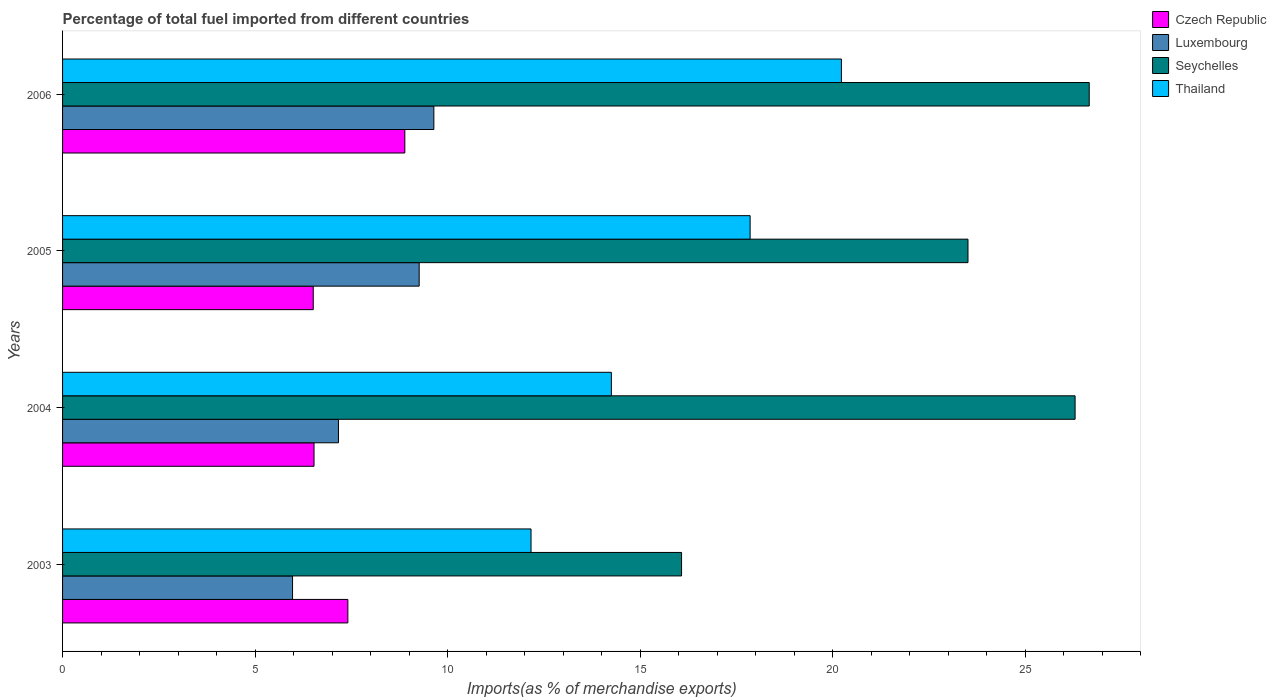How many different coloured bars are there?
Provide a short and direct response. 4. How many groups of bars are there?
Offer a very short reply. 4. How many bars are there on the 2nd tick from the bottom?
Provide a succinct answer. 4. What is the label of the 3rd group of bars from the top?
Keep it short and to the point. 2004. In how many cases, is the number of bars for a given year not equal to the number of legend labels?
Provide a succinct answer. 0. What is the percentage of imports to different countries in Czech Republic in 2006?
Give a very brief answer. 8.89. Across all years, what is the maximum percentage of imports to different countries in Luxembourg?
Give a very brief answer. 9.64. Across all years, what is the minimum percentage of imports to different countries in Seychelles?
Your response must be concise. 16.08. In which year was the percentage of imports to different countries in Seychelles minimum?
Make the answer very short. 2003. What is the total percentage of imports to different countries in Czech Republic in the graph?
Ensure brevity in your answer.  29.34. What is the difference between the percentage of imports to different countries in Czech Republic in 2005 and that in 2006?
Your answer should be compact. -2.38. What is the difference between the percentage of imports to different countries in Czech Republic in 2006 and the percentage of imports to different countries in Seychelles in 2003?
Keep it short and to the point. -7.19. What is the average percentage of imports to different countries in Seychelles per year?
Your answer should be very brief. 23.14. In the year 2006, what is the difference between the percentage of imports to different countries in Seychelles and percentage of imports to different countries in Czech Republic?
Ensure brevity in your answer.  17.78. What is the ratio of the percentage of imports to different countries in Czech Republic in 2005 to that in 2006?
Make the answer very short. 0.73. Is the difference between the percentage of imports to different countries in Seychelles in 2003 and 2004 greater than the difference between the percentage of imports to different countries in Czech Republic in 2003 and 2004?
Give a very brief answer. No. What is the difference between the highest and the second highest percentage of imports to different countries in Seychelles?
Ensure brevity in your answer.  0.37. What is the difference between the highest and the lowest percentage of imports to different countries in Thailand?
Your answer should be very brief. 8.06. In how many years, is the percentage of imports to different countries in Thailand greater than the average percentage of imports to different countries in Thailand taken over all years?
Your answer should be compact. 2. Is the sum of the percentage of imports to different countries in Seychelles in 2004 and 2005 greater than the maximum percentage of imports to different countries in Luxembourg across all years?
Ensure brevity in your answer.  Yes. What does the 3rd bar from the top in 2003 represents?
Provide a short and direct response. Luxembourg. What does the 1st bar from the bottom in 2006 represents?
Offer a very short reply. Czech Republic. Is it the case that in every year, the sum of the percentage of imports to different countries in Seychelles and percentage of imports to different countries in Czech Republic is greater than the percentage of imports to different countries in Luxembourg?
Make the answer very short. Yes. How many bars are there?
Offer a very short reply. 16. Are all the bars in the graph horizontal?
Your response must be concise. Yes. How many years are there in the graph?
Provide a short and direct response. 4. What is the difference between two consecutive major ticks on the X-axis?
Ensure brevity in your answer.  5. Does the graph contain any zero values?
Your answer should be compact. No. Does the graph contain grids?
Your answer should be compact. No. How many legend labels are there?
Make the answer very short. 4. What is the title of the graph?
Provide a succinct answer. Percentage of total fuel imported from different countries. What is the label or title of the X-axis?
Keep it short and to the point. Imports(as % of merchandise exports). What is the Imports(as % of merchandise exports) of Czech Republic in 2003?
Offer a terse response. 7.41. What is the Imports(as % of merchandise exports) of Luxembourg in 2003?
Keep it short and to the point. 5.97. What is the Imports(as % of merchandise exports) in Seychelles in 2003?
Provide a succinct answer. 16.08. What is the Imports(as % of merchandise exports) of Thailand in 2003?
Offer a very short reply. 12.17. What is the Imports(as % of merchandise exports) of Czech Republic in 2004?
Provide a short and direct response. 6.53. What is the Imports(as % of merchandise exports) of Luxembourg in 2004?
Make the answer very short. 7.17. What is the Imports(as % of merchandise exports) in Seychelles in 2004?
Keep it short and to the point. 26.3. What is the Imports(as % of merchandise exports) in Thailand in 2004?
Your answer should be very brief. 14.26. What is the Imports(as % of merchandise exports) of Czech Republic in 2005?
Give a very brief answer. 6.51. What is the Imports(as % of merchandise exports) in Luxembourg in 2005?
Your answer should be very brief. 9.26. What is the Imports(as % of merchandise exports) of Seychelles in 2005?
Offer a terse response. 23.52. What is the Imports(as % of merchandise exports) in Thailand in 2005?
Your answer should be very brief. 17.86. What is the Imports(as % of merchandise exports) of Czech Republic in 2006?
Keep it short and to the point. 8.89. What is the Imports(as % of merchandise exports) in Luxembourg in 2006?
Provide a succinct answer. 9.64. What is the Imports(as % of merchandise exports) in Seychelles in 2006?
Your response must be concise. 26.67. What is the Imports(as % of merchandise exports) of Thailand in 2006?
Ensure brevity in your answer.  20.23. Across all years, what is the maximum Imports(as % of merchandise exports) in Czech Republic?
Give a very brief answer. 8.89. Across all years, what is the maximum Imports(as % of merchandise exports) of Luxembourg?
Offer a terse response. 9.64. Across all years, what is the maximum Imports(as % of merchandise exports) in Seychelles?
Offer a terse response. 26.67. Across all years, what is the maximum Imports(as % of merchandise exports) in Thailand?
Give a very brief answer. 20.23. Across all years, what is the minimum Imports(as % of merchandise exports) of Czech Republic?
Make the answer very short. 6.51. Across all years, what is the minimum Imports(as % of merchandise exports) of Luxembourg?
Your answer should be very brief. 5.97. Across all years, what is the minimum Imports(as % of merchandise exports) of Seychelles?
Your response must be concise. 16.08. Across all years, what is the minimum Imports(as % of merchandise exports) in Thailand?
Your answer should be compact. 12.17. What is the total Imports(as % of merchandise exports) of Czech Republic in the graph?
Offer a very short reply. 29.34. What is the total Imports(as % of merchandise exports) in Luxembourg in the graph?
Ensure brevity in your answer.  32.05. What is the total Imports(as % of merchandise exports) of Seychelles in the graph?
Make the answer very short. 92.56. What is the total Imports(as % of merchandise exports) in Thailand in the graph?
Give a very brief answer. 64.51. What is the difference between the Imports(as % of merchandise exports) of Czech Republic in 2003 and that in 2004?
Offer a very short reply. 0.88. What is the difference between the Imports(as % of merchandise exports) of Luxembourg in 2003 and that in 2004?
Provide a succinct answer. -1.19. What is the difference between the Imports(as % of merchandise exports) in Seychelles in 2003 and that in 2004?
Your response must be concise. -10.22. What is the difference between the Imports(as % of merchandise exports) in Thailand in 2003 and that in 2004?
Ensure brevity in your answer.  -2.09. What is the difference between the Imports(as % of merchandise exports) of Czech Republic in 2003 and that in 2005?
Offer a very short reply. 0.9. What is the difference between the Imports(as % of merchandise exports) in Luxembourg in 2003 and that in 2005?
Offer a terse response. -3.29. What is the difference between the Imports(as % of merchandise exports) of Seychelles in 2003 and that in 2005?
Make the answer very short. -7.44. What is the difference between the Imports(as % of merchandise exports) of Thailand in 2003 and that in 2005?
Offer a very short reply. -5.69. What is the difference between the Imports(as % of merchandise exports) in Czech Republic in 2003 and that in 2006?
Ensure brevity in your answer.  -1.48. What is the difference between the Imports(as % of merchandise exports) in Luxembourg in 2003 and that in 2006?
Ensure brevity in your answer.  -3.67. What is the difference between the Imports(as % of merchandise exports) in Seychelles in 2003 and that in 2006?
Your answer should be very brief. -10.59. What is the difference between the Imports(as % of merchandise exports) of Thailand in 2003 and that in 2006?
Give a very brief answer. -8.06. What is the difference between the Imports(as % of merchandise exports) of Czech Republic in 2004 and that in 2005?
Make the answer very short. 0.02. What is the difference between the Imports(as % of merchandise exports) of Luxembourg in 2004 and that in 2005?
Offer a terse response. -2.1. What is the difference between the Imports(as % of merchandise exports) of Seychelles in 2004 and that in 2005?
Offer a very short reply. 2.78. What is the difference between the Imports(as % of merchandise exports) in Thailand in 2004 and that in 2005?
Ensure brevity in your answer.  -3.6. What is the difference between the Imports(as % of merchandise exports) of Czech Republic in 2004 and that in 2006?
Your answer should be compact. -2.36. What is the difference between the Imports(as % of merchandise exports) of Luxembourg in 2004 and that in 2006?
Offer a terse response. -2.48. What is the difference between the Imports(as % of merchandise exports) in Seychelles in 2004 and that in 2006?
Offer a terse response. -0.37. What is the difference between the Imports(as % of merchandise exports) in Thailand in 2004 and that in 2006?
Offer a terse response. -5.97. What is the difference between the Imports(as % of merchandise exports) of Czech Republic in 2005 and that in 2006?
Provide a short and direct response. -2.38. What is the difference between the Imports(as % of merchandise exports) in Luxembourg in 2005 and that in 2006?
Make the answer very short. -0.38. What is the difference between the Imports(as % of merchandise exports) of Seychelles in 2005 and that in 2006?
Give a very brief answer. -3.15. What is the difference between the Imports(as % of merchandise exports) of Thailand in 2005 and that in 2006?
Provide a succinct answer. -2.37. What is the difference between the Imports(as % of merchandise exports) in Czech Republic in 2003 and the Imports(as % of merchandise exports) in Luxembourg in 2004?
Make the answer very short. 0.24. What is the difference between the Imports(as % of merchandise exports) of Czech Republic in 2003 and the Imports(as % of merchandise exports) of Seychelles in 2004?
Your answer should be very brief. -18.89. What is the difference between the Imports(as % of merchandise exports) of Czech Republic in 2003 and the Imports(as % of merchandise exports) of Thailand in 2004?
Keep it short and to the point. -6.84. What is the difference between the Imports(as % of merchandise exports) in Luxembourg in 2003 and the Imports(as % of merchandise exports) in Seychelles in 2004?
Provide a short and direct response. -20.33. What is the difference between the Imports(as % of merchandise exports) of Luxembourg in 2003 and the Imports(as % of merchandise exports) of Thailand in 2004?
Ensure brevity in your answer.  -8.28. What is the difference between the Imports(as % of merchandise exports) of Seychelles in 2003 and the Imports(as % of merchandise exports) of Thailand in 2004?
Keep it short and to the point. 1.82. What is the difference between the Imports(as % of merchandise exports) of Czech Republic in 2003 and the Imports(as % of merchandise exports) of Luxembourg in 2005?
Provide a short and direct response. -1.85. What is the difference between the Imports(as % of merchandise exports) of Czech Republic in 2003 and the Imports(as % of merchandise exports) of Seychelles in 2005?
Your answer should be very brief. -16.11. What is the difference between the Imports(as % of merchandise exports) in Czech Republic in 2003 and the Imports(as % of merchandise exports) in Thailand in 2005?
Your response must be concise. -10.45. What is the difference between the Imports(as % of merchandise exports) in Luxembourg in 2003 and the Imports(as % of merchandise exports) in Seychelles in 2005?
Make the answer very short. -17.54. What is the difference between the Imports(as % of merchandise exports) in Luxembourg in 2003 and the Imports(as % of merchandise exports) in Thailand in 2005?
Ensure brevity in your answer.  -11.89. What is the difference between the Imports(as % of merchandise exports) in Seychelles in 2003 and the Imports(as % of merchandise exports) in Thailand in 2005?
Make the answer very short. -1.78. What is the difference between the Imports(as % of merchandise exports) of Czech Republic in 2003 and the Imports(as % of merchandise exports) of Luxembourg in 2006?
Provide a succinct answer. -2.23. What is the difference between the Imports(as % of merchandise exports) in Czech Republic in 2003 and the Imports(as % of merchandise exports) in Seychelles in 2006?
Provide a succinct answer. -19.26. What is the difference between the Imports(as % of merchandise exports) of Czech Republic in 2003 and the Imports(as % of merchandise exports) of Thailand in 2006?
Provide a succinct answer. -12.82. What is the difference between the Imports(as % of merchandise exports) in Luxembourg in 2003 and the Imports(as % of merchandise exports) in Seychelles in 2006?
Keep it short and to the point. -20.69. What is the difference between the Imports(as % of merchandise exports) of Luxembourg in 2003 and the Imports(as % of merchandise exports) of Thailand in 2006?
Make the answer very short. -14.26. What is the difference between the Imports(as % of merchandise exports) in Seychelles in 2003 and the Imports(as % of merchandise exports) in Thailand in 2006?
Provide a short and direct response. -4.15. What is the difference between the Imports(as % of merchandise exports) of Czech Republic in 2004 and the Imports(as % of merchandise exports) of Luxembourg in 2005?
Your answer should be compact. -2.73. What is the difference between the Imports(as % of merchandise exports) of Czech Republic in 2004 and the Imports(as % of merchandise exports) of Seychelles in 2005?
Offer a terse response. -16.99. What is the difference between the Imports(as % of merchandise exports) in Czech Republic in 2004 and the Imports(as % of merchandise exports) in Thailand in 2005?
Give a very brief answer. -11.33. What is the difference between the Imports(as % of merchandise exports) in Luxembourg in 2004 and the Imports(as % of merchandise exports) in Seychelles in 2005?
Provide a succinct answer. -16.35. What is the difference between the Imports(as % of merchandise exports) of Luxembourg in 2004 and the Imports(as % of merchandise exports) of Thailand in 2005?
Keep it short and to the point. -10.69. What is the difference between the Imports(as % of merchandise exports) in Seychelles in 2004 and the Imports(as % of merchandise exports) in Thailand in 2005?
Your answer should be compact. 8.44. What is the difference between the Imports(as % of merchandise exports) of Czech Republic in 2004 and the Imports(as % of merchandise exports) of Luxembourg in 2006?
Ensure brevity in your answer.  -3.11. What is the difference between the Imports(as % of merchandise exports) in Czech Republic in 2004 and the Imports(as % of merchandise exports) in Seychelles in 2006?
Keep it short and to the point. -20.14. What is the difference between the Imports(as % of merchandise exports) of Czech Republic in 2004 and the Imports(as % of merchandise exports) of Thailand in 2006?
Ensure brevity in your answer.  -13.7. What is the difference between the Imports(as % of merchandise exports) of Luxembourg in 2004 and the Imports(as % of merchandise exports) of Seychelles in 2006?
Keep it short and to the point. -19.5. What is the difference between the Imports(as % of merchandise exports) in Luxembourg in 2004 and the Imports(as % of merchandise exports) in Thailand in 2006?
Your answer should be very brief. -13.06. What is the difference between the Imports(as % of merchandise exports) in Seychelles in 2004 and the Imports(as % of merchandise exports) in Thailand in 2006?
Your answer should be very brief. 6.07. What is the difference between the Imports(as % of merchandise exports) in Czech Republic in 2005 and the Imports(as % of merchandise exports) in Luxembourg in 2006?
Keep it short and to the point. -3.13. What is the difference between the Imports(as % of merchandise exports) in Czech Republic in 2005 and the Imports(as % of merchandise exports) in Seychelles in 2006?
Provide a succinct answer. -20.16. What is the difference between the Imports(as % of merchandise exports) of Czech Republic in 2005 and the Imports(as % of merchandise exports) of Thailand in 2006?
Make the answer very short. -13.72. What is the difference between the Imports(as % of merchandise exports) of Luxembourg in 2005 and the Imports(as % of merchandise exports) of Seychelles in 2006?
Offer a terse response. -17.4. What is the difference between the Imports(as % of merchandise exports) of Luxembourg in 2005 and the Imports(as % of merchandise exports) of Thailand in 2006?
Keep it short and to the point. -10.97. What is the difference between the Imports(as % of merchandise exports) of Seychelles in 2005 and the Imports(as % of merchandise exports) of Thailand in 2006?
Your answer should be very brief. 3.29. What is the average Imports(as % of merchandise exports) of Czech Republic per year?
Provide a short and direct response. 7.34. What is the average Imports(as % of merchandise exports) of Luxembourg per year?
Your response must be concise. 8.01. What is the average Imports(as % of merchandise exports) of Seychelles per year?
Your response must be concise. 23.14. What is the average Imports(as % of merchandise exports) in Thailand per year?
Keep it short and to the point. 16.13. In the year 2003, what is the difference between the Imports(as % of merchandise exports) of Czech Republic and Imports(as % of merchandise exports) of Luxembourg?
Keep it short and to the point. 1.44. In the year 2003, what is the difference between the Imports(as % of merchandise exports) in Czech Republic and Imports(as % of merchandise exports) in Seychelles?
Provide a succinct answer. -8.67. In the year 2003, what is the difference between the Imports(as % of merchandise exports) in Czech Republic and Imports(as % of merchandise exports) in Thailand?
Your response must be concise. -4.76. In the year 2003, what is the difference between the Imports(as % of merchandise exports) of Luxembourg and Imports(as % of merchandise exports) of Seychelles?
Your response must be concise. -10.1. In the year 2003, what is the difference between the Imports(as % of merchandise exports) of Luxembourg and Imports(as % of merchandise exports) of Thailand?
Your response must be concise. -6.19. In the year 2003, what is the difference between the Imports(as % of merchandise exports) of Seychelles and Imports(as % of merchandise exports) of Thailand?
Make the answer very short. 3.91. In the year 2004, what is the difference between the Imports(as % of merchandise exports) in Czech Republic and Imports(as % of merchandise exports) in Luxembourg?
Provide a succinct answer. -0.63. In the year 2004, what is the difference between the Imports(as % of merchandise exports) in Czech Republic and Imports(as % of merchandise exports) in Seychelles?
Ensure brevity in your answer.  -19.77. In the year 2004, what is the difference between the Imports(as % of merchandise exports) of Czech Republic and Imports(as % of merchandise exports) of Thailand?
Your answer should be compact. -7.72. In the year 2004, what is the difference between the Imports(as % of merchandise exports) in Luxembourg and Imports(as % of merchandise exports) in Seychelles?
Your response must be concise. -19.13. In the year 2004, what is the difference between the Imports(as % of merchandise exports) in Luxembourg and Imports(as % of merchandise exports) in Thailand?
Your response must be concise. -7.09. In the year 2004, what is the difference between the Imports(as % of merchandise exports) in Seychelles and Imports(as % of merchandise exports) in Thailand?
Provide a succinct answer. 12.04. In the year 2005, what is the difference between the Imports(as % of merchandise exports) of Czech Republic and Imports(as % of merchandise exports) of Luxembourg?
Your response must be concise. -2.75. In the year 2005, what is the difference between the Imports(as % of merchandise exports) of Czech Republic and Imports(as % of merchandise exports) of Seychelles?
Your response must be concise. -17.01. In the year 2005, what is the difference between the Imports(as % of merchandise exports) of Czech Republic and Imports(as % of merchandise exports) of Thailand?
Make the answer very short. -11.35. In the year 2005, what is the difference between the Imports(as % of merchandise exports) of Luxembourg and Imports(as % of merchandise exports) of Seychelles?
Provide a succinct answer. -14.25. In the year 2005, what is the difference between the Imports(as % of merchandise exports) in Luxembourg and Imports(as % of merchandise exports) in Thailand?
Provide a short and direct response. -8.6. In the year 2005, what is the difference between the Imports(as % of merchandise exports) of Seychelles and Imports(as % of merchandise exports) of Thailand?
Give a very brief answer. 5.66. In the year 2006, what is the difference between the Imports(as % of merchandise exports) in Czech Republic and Imports(as % of merchandise exports) in Luxembourg?
Provide a succinct answer. -0.75. In the year 2006, what is the difference between the Imports(as % of merchandise exports) in Czech Republic and Imports(as % of merchandise exports) in Seychelles?
Provide a succinct answer. -17.78. In the year 2006, what is the difference between the Imports(as % of merchandise exports) in Czech Republic and Imports(as % of merchandise exports) in Thailand?
Offer a terse response. -11.34. In the year 2006, what is the difference between the Imports(as % of merchandise exports) in Luxembourg and Imports(as % of merchandise exports) in Seychelles?
Your response must be concise. -17.02. In the year 2006, what is the difference between the Imports(as % of merchandise exports) in Luxembourg and Imports(as % of merchandise exports) in Thailand?
Ensure brevity in your answer.  -10.59. In the year 2006, what is the difference between the Imports(as % of merchandise exports) in Seychelles and Imports(as % of merchandise exports) in Thailand?
Offer a terse response. 6.44. What is the ratio of the Imports(as % of merchandise exports) in Czech Republic in 2003 to that in 2004?
Provide a short and direct response. 1.13. What is the ratio of the Imports(as % of merchandise exports) in Luxembourg in 2003 to that in 2004?
Offer a very short reply. 0.83. What is the ratio of the Imports(as % of merchandise exports) of Seychelles in 2003 to that in 2004?
Provide a short and direct response. 0.61. What is the ratio of the Imports(as % of merchandise exports) in Thailand in 2003 to that in 2004?
Offer a very short reply. 0.85. What is the ratio of the Imports(as % of merchandise exports) of Czech Republic in 2003 to that in 2005?
Give a very brief answer. 1.14. What is the ratio of the Imports(as % of merchandise exports) in Luxembourg in 2003 to that in 2005?
Offer a terse response. 0.64. What is the ratio of the Imports(as % of merchandise exports) in Seychelles in 2003 to that in 2005?
Keep it short and to the point. 0.68. What is the ratio of the Imports(as % of merchandise exports) in Thailand in 2003 to that in 2005?
Make the answer very short. 0.68. What is the ratio of the Imports(as % of merchandise exports) of Czech Republic in 2003 to that in 2006?
Offer a terse response. 0.83. What is the ratio of the Imports(as % of merchandise exports) in Luxembourg in 2003 to that in 2006?
Make the answer very short. 0.62. What is the ratio of the Imports(as % of merchandise exports) of Seychelles in 2003 to that in 2006?
Keep it short and to the point. 0.6. What is the ratio of the Imports(as % of merchandise exports) of Thailand in 2003 to that in 2006?
Offer a terse response. 0.6. What is the ratio of the Imports(as % of merchandise exports) in Czech Republic in 2004 to that in 2005?
Give a very brief answer. 1. What is the ratio of the Imports(as % of merchandise exports) in Luxembourg in 2004 to that in 2005?
Give a very brief answer. 0.77. What is the ratio of the Imports(as % of merchandise exports) of Seychelles in 2004 to that in 2005?
Make the answer very short. 1.12. What is the ratio of the Imports(as % of merchandise exports) of Thailand in 2004 to that in 2005?
Your answer should be compact. 0.8. What is the ratio of the Imports(as % of merchandise exports) of Czech Republic in 2004 to that in 2006?
Your response must be concise. 0.73. What is the ratio of the Imports(as % of merchandise exports) in Luxembourg in 2004 to that in 2006?
Offer a terse response. 0.74. What is the ratio of the Imports(as % of merchandise exports) in Seychelles in 2004 to that in 2006?
Offer a very short reply. 0.99. What is the ratio of the Imports(as % of merchandise exports) in Thailand in 2004 to that in 2006?
Your response must be concise. 0.7. What is the ratio of the Imports(as % of merchandise exports) in Czech Republic in 2005 to that in 2006?
Keep it short and to the point. 0.73. What is the ratio of the Imports(as % of merchandise exports) in Luxembourg in 2005 to that in 2006?
Ensure brevity in your answer.  0.96. What is the ratio of the Imports(as % of merchandise exports) of Seychelles in 2005 to that in 2006?
Your answer should be compact. 0.88. What is the ratio of the Imports(as % of merchandise exports) in Thailand in 2005 to that in 2006?
Provide a short and direct response. 0.88. What is the difference between the highest and the second highest Imports(as % of merchandise exports) in Czech Republic?
Provide a succinct answer. 1.48. What is the difference between the highest and the second highest Imports(as % of merchandise exports) of Luxembourg?
Make the answer very short. 0.38. What is the difference between the highest and the second highest Imports(as % of merchandise exports) in Seychelles?
Your response must be concise. 0.37. What is the difference between the highest and the second highest Imports(as % of merchandise exports) in Thailand?
Give a very brief answer. 2.37. What is the difference between the highest and the lowest Imports(as % of merchandise exports) of Czech Republic?
Give a very brief answer. 2.38. What is the difference between the highest and the lowest Imports(as % of merchandise exports) in Luxembourg?
Your answer should be very brief. 3.67. What is the difference between the highest and the lowest Imports(as % of merchandise exports) of Seychelles?
Make the answer very short. 10.59. What is the difference between the highest and the lowest Imports(as % of merchandise exports) of Thailand?
Provide a short and direct response. 8.06. 